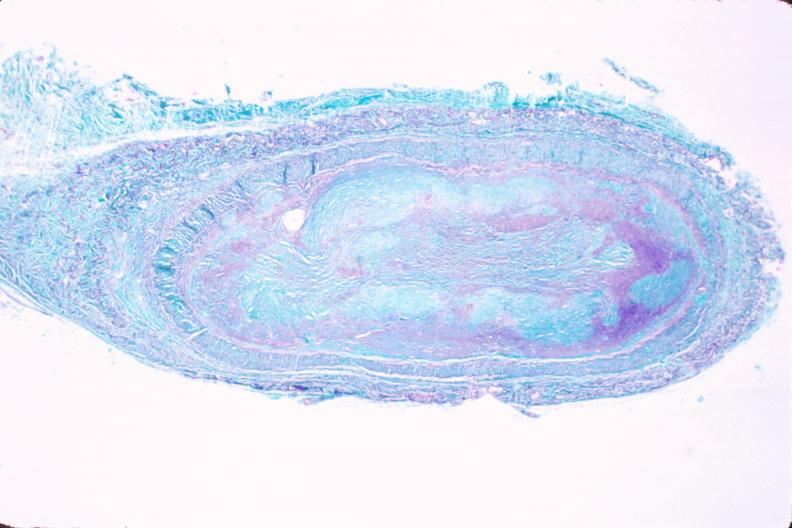s opened muscle present?
Answer the question using a single word or phrase. No 